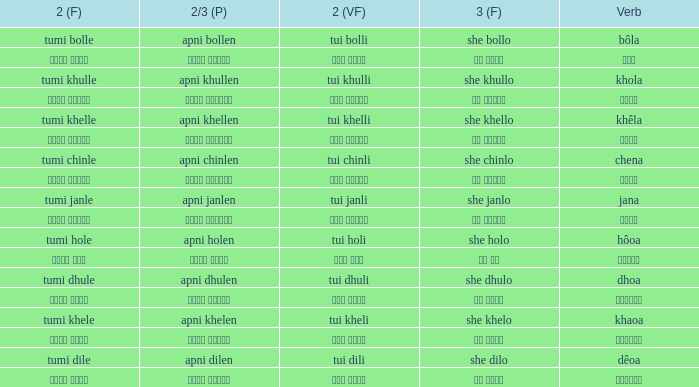What is the verb for তুমি খেলে? খাওয়া. 